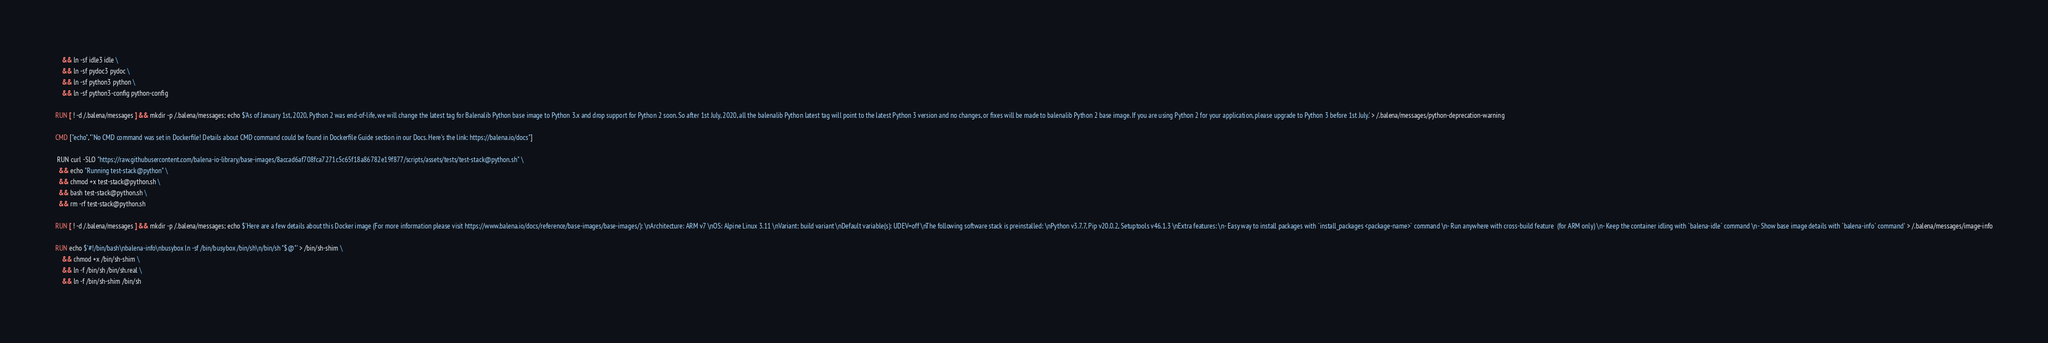Convert code to text. <code><loc_0><loc_0><loc_500><loc_500><_Dockerfile_>	&& ln -sf idle3 idle \
	&& ln -sf pydoc3 pydoc \
	&& ln -sf python3 python \
	&& ln -sf python3-config python-config

RUN [ ! -d /.balena/messages ] && mkdir -p /.balena/messages; echo $'As of January 1st, 2020, Python 2 was end-of-life, we will change the latest tag for Balenalib Python base image to Python 3.x and drop support for Python 2 soon. So after 1st July, 2020, all the balenalib Python latest tag will point to the latest Python 3 version and no changes, or fixes will be made to balenalib Python 2 base image. If you are using Python 2 for your application, please upgrade to Python 3 before 1st July.' > /.balena/messages/python-deprecation-warning

CMD ["echo","'No CMD command was set in Dockerfile! Details about CMD command could be found in Dockerfile Guide section in our Docs. Here's the link: https://balena.io/docs"]

 RUN curl -SLO "https://raw.githubusercontent.com/balena-io-library/base-images/8accad6af708fca7271c5c65f18a86782e19f877/scripts/assets/tests/test-stack@python.sh" \
  && echo "Running test-stack@python" \
  && chmod +x test-stack@python.sh \
  && bash test-stack@python.sh \
  && rm -rf test-stack@python.sh 

RUN [ ! -d /.balena/messages ] && mkdir -p /.balena/messages; echo $'Here are a few details about this Docker image (For more information please visit https://www.balena.io/docs/reference/base-images/base-images/): \nArchitecture: ARM v7 \nOS: Alpine Linux 3.11 \nVariant: build variant \nDefault variable(s): UDEV=off \nThe following software stack is preinstalled: \nPython v3.7.7, Pip v20.0.2, Setuptools v46.1.3 \nExtra features: \n- Easy way to install packages with `install_packages <package-name>` command \n- Run anywhere with cross-build feature  (for ARM only) \n- Keep the container idling with `balena-idle` command \n- Show base image details with `balena-info` command' > /.balena/messages/image-info

RUN echo $'#!/bin/bash\nbalena-info\nbusybox ln -sf /bin/busybox /bin/sh\n/bin/sh "$@"' > /bin/sh-shim \
	&& chmod +x /bin/sh-shim \
	&& ln -f /bin/sh /bin/sh.real \
	&& ln -f /bin/sh-shim /bin/sh</code> 